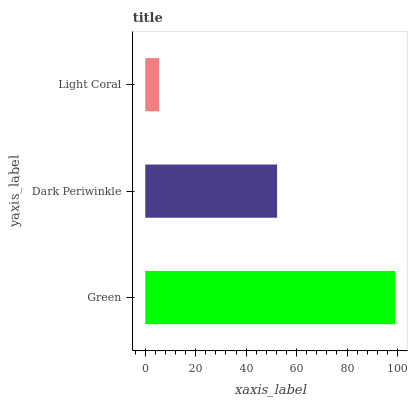Is Light Coral the minimum?
Answer yes or no. Yes. Is Green the maximum?
Answer yes or no. Yes. Is Dark Periwinkle the minimum?
Answer yes or no. No. Is Dark Periwinkle the maximum?
Answer yes or no. No. Is Green greater than Dark Periwinkle?
Answer yes or no. Yes. Is Dark Periwinkle less than Green?
Answer yes or no. Yes. Is Dark Periwinkle greater than Green?
Answer yes or no. No. Is Green less than Dark Periwinkle?
Answer yes or no. No. Is Dark Periwinkle the high median?
Answer yes or no. Yes. Is Dark Periwinkle the low median?
Answer yes or no. Yes. Is Green the high median?
Answer yes or no. No. Is Green the low median?
Answer yes or no. No. 